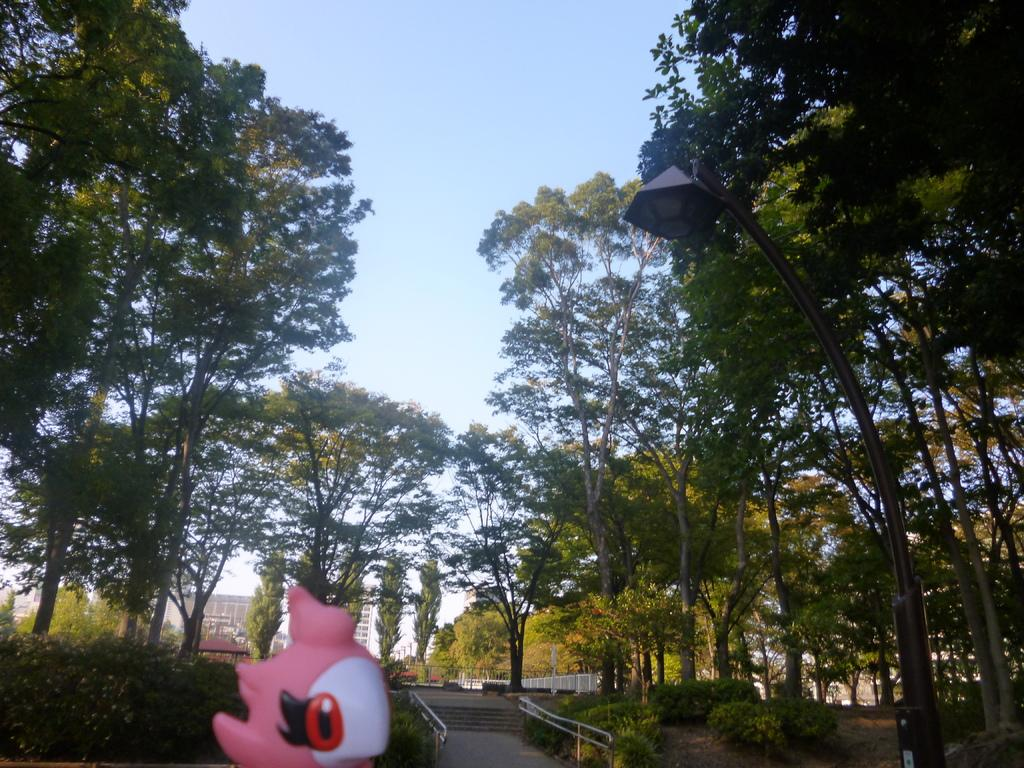What object is located at the bottom of the image? There is a toy at the bottom of the image. What can be seen in the distance in the image? There are trees, metal rods, and buildings in the background of the image. What type of fang can be seen in the image? There is no fang present in the image. What impulse might the toy have in the image? The toy is an inanimate object and does not have impulses. 